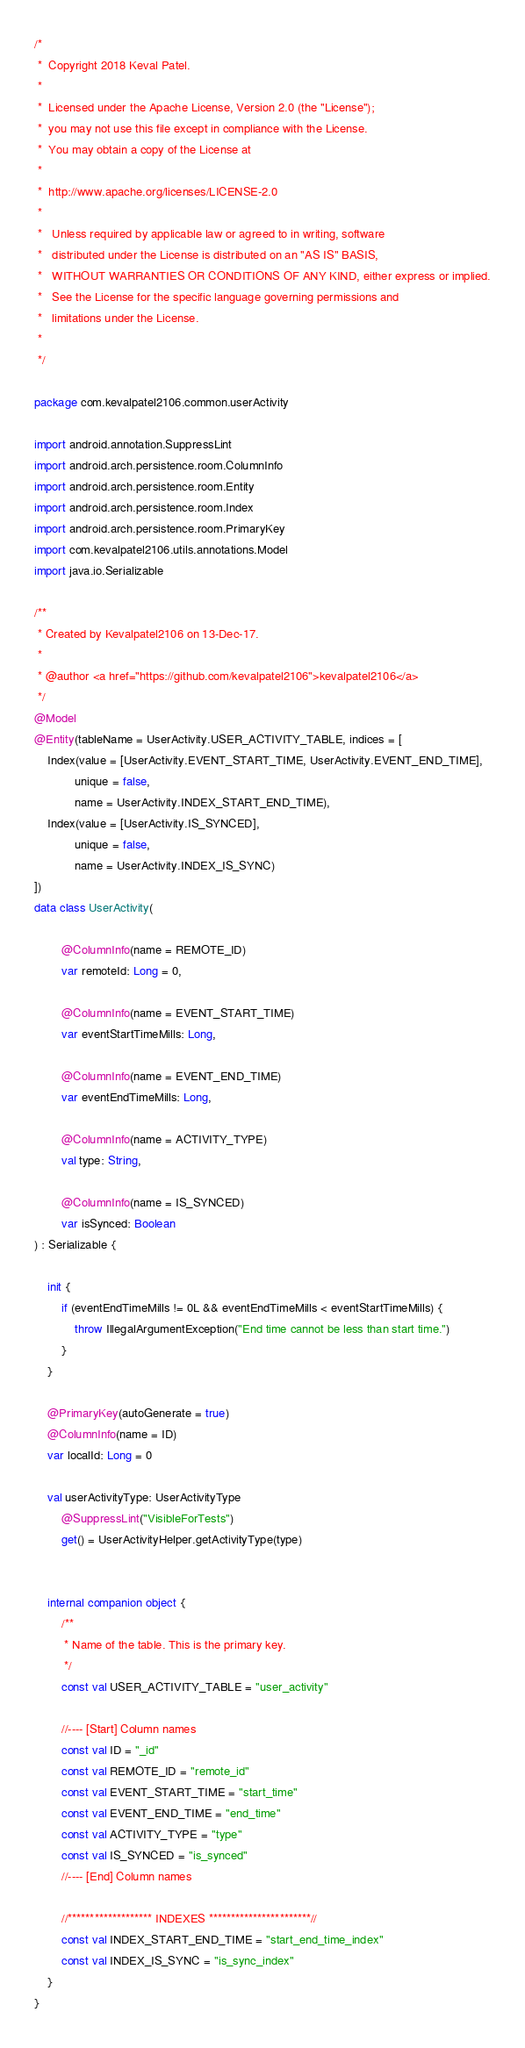<code> <loc_0><loc_0><loc_500><loc_500><_Kotlin_>/*
 *  Copyright 2018 Keval Patel.
 *
 *  Licensed under the Apache License, Version 2.0 (the "License");
 *  you may not use this file except in compliance with the License.
 *  You may obtain a copy of the License at
 *
 *  http://www.apache.org/licenses/LICENSE-2.0
 *
 *   Unless required by applicable law or agreed to in writing, software
 *   distributed under the License is distributed on an "AS IS" BASIS,
 *   WITHOUT WARRANTIES OR CONDITIONS OF ANY KIND, either express or implied.
 *   See the License for the specific language governing permissions and
 *   limitations under the License.
 *
 */

package com.kevalpatel2106.common.userActivity

import android.annotation.SuppressLint
import android.arch.persistence.room.ColumnInfo
import android.arch.persistence.room.Entity
import android.arch.persistence.room.Index
import android.arch.persistence.room.PrimaryKey
import com.kevalpatel2106.utils.annotations.Model
import java.io.Serializable

/**
 * Created by Kevalpatel2106 on 13-Dec-17.
 *
 * @author <a href="https://github.com/kevalpatel2106">kevalpatel2106</a>
 */
@Model
@Entity(tableName = UserActivity.USER_ACTIVITY_TABLE, indices = [
    Index(value = [UserActivity.EVENT_START_TIME, UserActivity.EVENT_END_TIME],
            unique = false,
            name = UserActivity.INDEX_START_END_TIME),
    Index(value = [UserActivity.IS_SYNCED],
            unique = false,
            name = UserActivity.INDEX_IS_SYNC)
])
data class UserActivity(

        @ColumnInfo(name = REMOTE_ID)
        var remoteId: Long = 0,

        @ColumnInfo(name = EVENT_START_TIME)
        var eventStartTimeMills: Long,

        @ColumnInfo(name = EVENT_END_TIME)
        var eventEndTimeMills: Long,

        @ColumnInfo(name = ACTIVITY_TYPE)
        val type: String,

        @ColumnInfo(name = IS_SYNCED)
        var isSynced: Boolean
) : Serializable {

    init {
        if (eventEndTimeMills != 0L && eventEndTimeMills < eventStartTimeMills) {
            throw IllegalArgumentException("End time cannot be less than start time.")
        }
    }

    @PrimaryKey(autoGenerate = true)
    @ColumnInfo(name = ID)
    var localId: Long = 0

    val userActivityType: UserActivityType
        @SuppressLint("VisibleForTests")
        get() = UserActivityHelper.getActivityType(type)


    internal companion object {
        /**
         * Name of the table. This is the primary key.
         */
        const val USER_ACTIVITY_TABLE = "user_activity"

        //---- [Start] Column names
        const val ID = "_id"
        const val REMOTE_ID = "remote_id"
        const val EVENT_START_TIME = "start_time"
        const val EVENT_END_TIME = "end_time"
        const val ACTIVITY_TYPE = "type"
        const val IS_SYNCED = "is_synced"
        //---- [End] Column names

        //******************* INDEXES ***********************//
        const val INDEX_START_END_TIME = "start_end_time_index"
        const val INDEX_IS_SYNC = "is_sync_index"
    }
}
</code> 